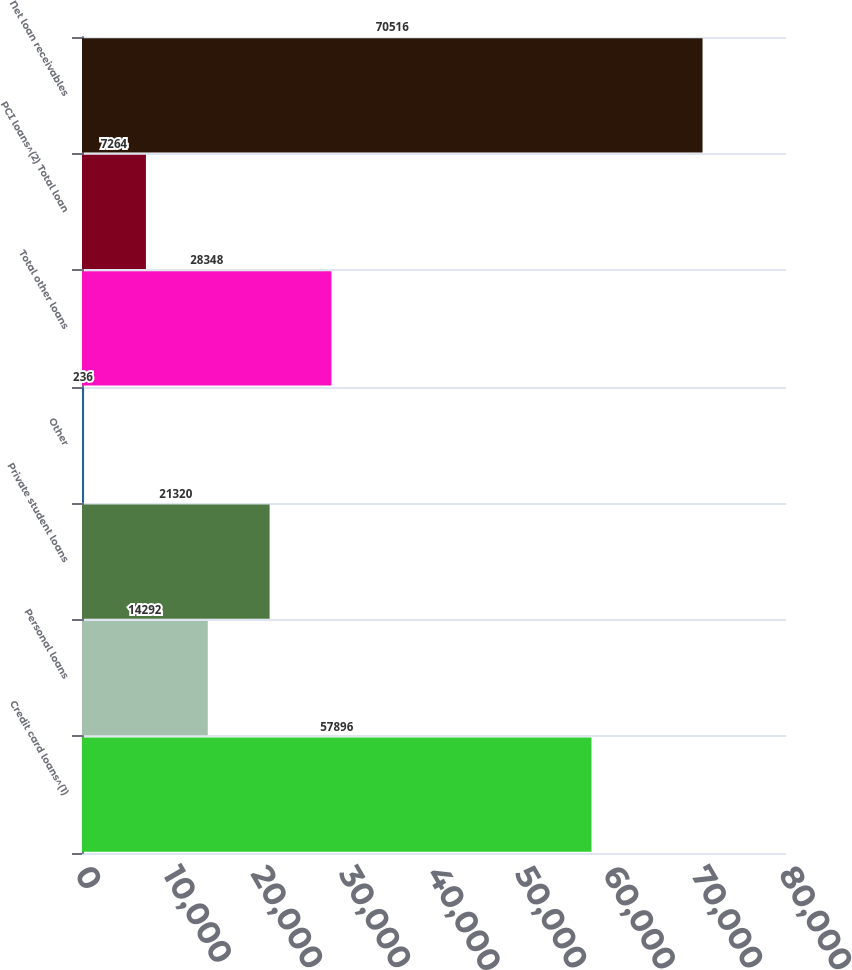Convert chart. <chart><loc_0><loc_0><loc_500><loc_500><bar_chart><fcel>Credit card loans^(1)<fcel>Personal loans<fcel>Private student loans<fcel>Other<fcel>Total other loans<fcel>PCI loans^(2) Total loan<fcel>Net loan receivables<nl><fcel>57896<fcel>14292<fcel>21320<fcel>236<fcel>28348<fcel>7264<fcel>70516<nl></chart> 